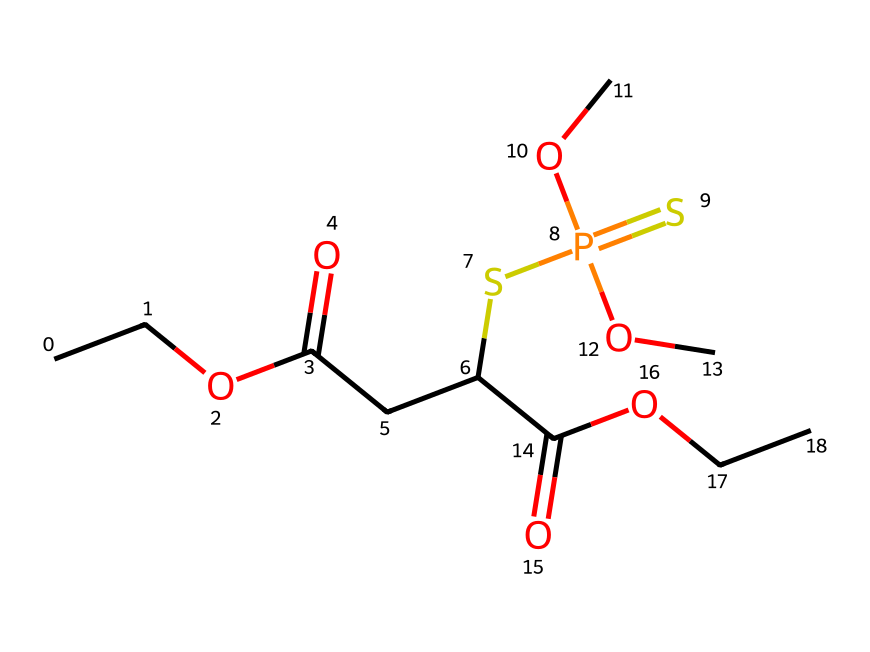What is the longest carbon chain in the molecule? Upon analyzing the SMILES representation, the longest continuous segment of carbon atoms is identified. Here, the longest chain consists of 4 carbon atoms (CCOC) extending to the central grouping before branching off.
Answer: 4 How many oxygen atoms are present in this structure? By examining the SMILES, each occurrence of 'O' indicates an oxygen atom. Counting reveals a total of 5 oxygen atoms present in this chemical structure.
Answer: 5 What functional groups are evident in the molecule? Analyzing the components of the SMILES notation, several functional groups are identifiable, including ester (–COO–) and thiol (–SH) groups, revealing the versatility of this pesticide.
Answer: ester, thiol What type of chemical compound is represented here? This SMILES notation corresponds to an organophosphate compound, recognizing the presence of a phosphorus atom and its linkage with organic groups distinguishing it from other pesticide types.
Answer: organophosphate Which atom serves as the central atom in the organophosphate group? In this chemical structure, phosphorus (P) is the distinct central atom found directly connected to sulfur and other groups, classifying it within organophosphate pesticides.
Answer: phosphorus 